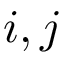Convert formula to latex. <formula><loc_0><loc_0><loc_500><loc_500>i , j</formula> 